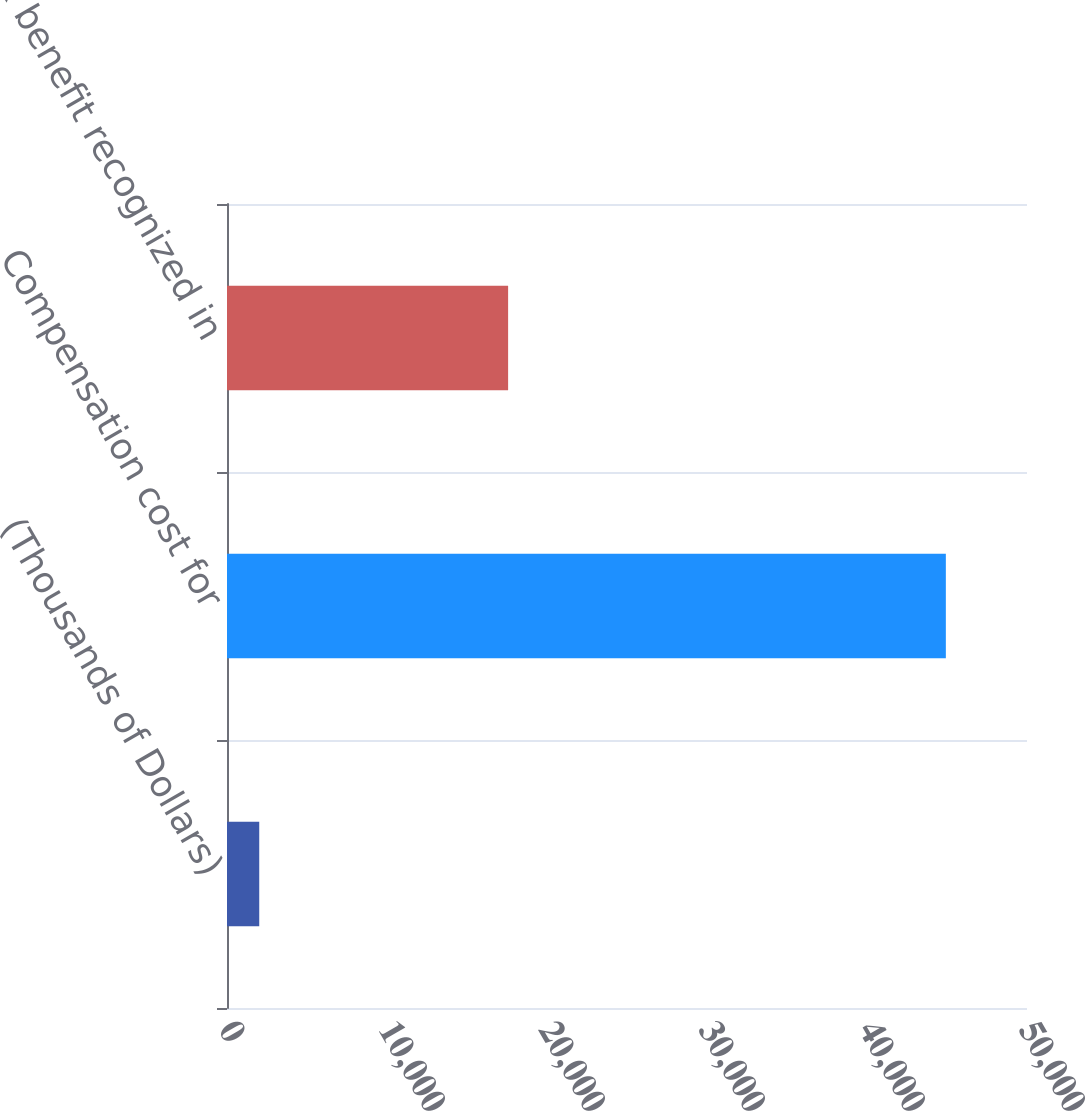<chart> <loc_0><loc_0><loc_500><loc_500><bar_chart><fcel>(Thousands of Dollars)<fcel>Compensation cost for<fcel>Tax benefit recognized in<nl><fcel>2015<fcel>44928<fcel>17570<nl></chart> 